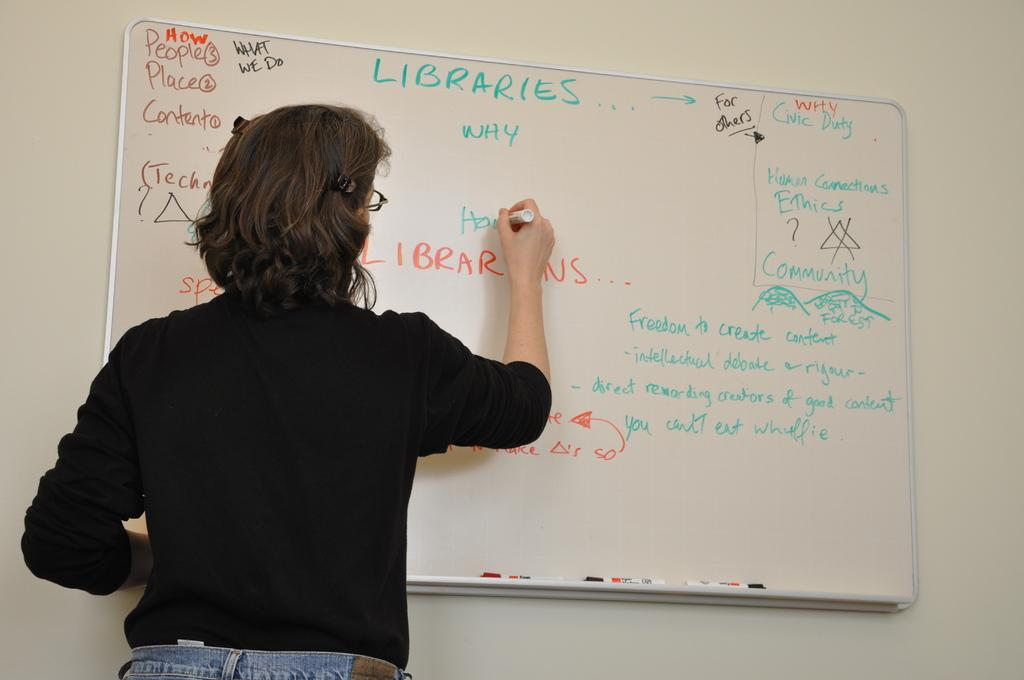What is the main subject of the image? There is a person standing in the image. Can you describe the background of the image? There is a board with written text in the background of the image. What type of pear is being advertised in the image? There is no pear or advertisement present in the image. 